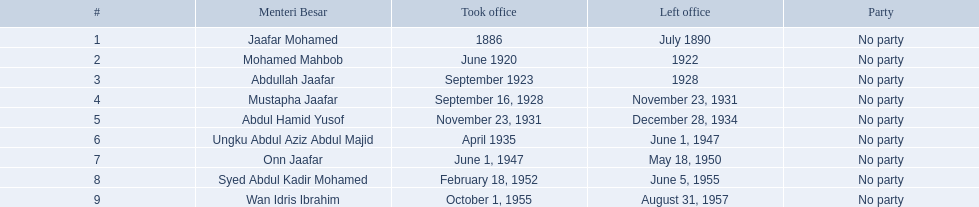Which chief ministers assumed their roles in the 1920s? Mohamed Mahbob, Abdullah Jaafar, Mustapha Jaafar. Among them, who held the position for just two years? Mohamed Mahbob. 